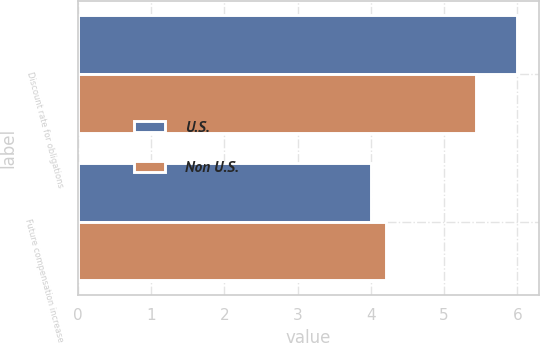Convert chart to OTSL. <chart><loc_0><loc_0><loc_500><loc_500><stacked_bar_chart><ecel><fcel>Discount rate for obligations<fcel>Future compensation increase<nl><fcel>U.S.<fcel>6<fcel>4<nl><fcel>Non U.S.<fcel>5.44<fcel>4.21<nl></chart> 